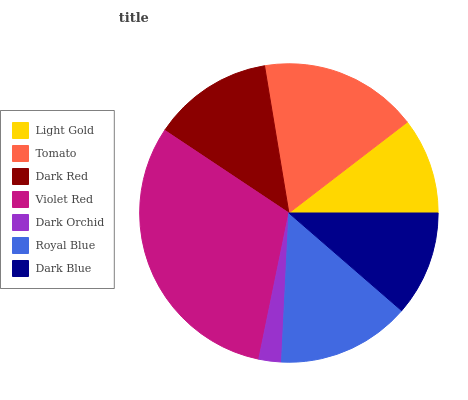Is Dark Orchid the minimum?
Answer yes or no. Yes. Is Violet Red the maximum?
Answer yes or no. Yes. Is Tomato the minimum?
Answer yes or no. No. Is Tomato the maximum?
Answer yes or no. No. Is Tomato greater than Light Gold?
Answer yes or no. Yes. Is Light Gold less than Tomato?
Answer yes or no. Yes. Is Light Gold greater than Tomato?
Answer yes or no. No. Is Tomato less than Light Gold?
Answer yes or no. No. Is Dark Red the high median?
Answer yes or no. Yes. Is Dark Red the low median?
Answer yes or no. Yes. Is Royal Blue the high median?
Answer yes or no. No. Is Dark Orchid the low median?
Answer yes or no. No. 